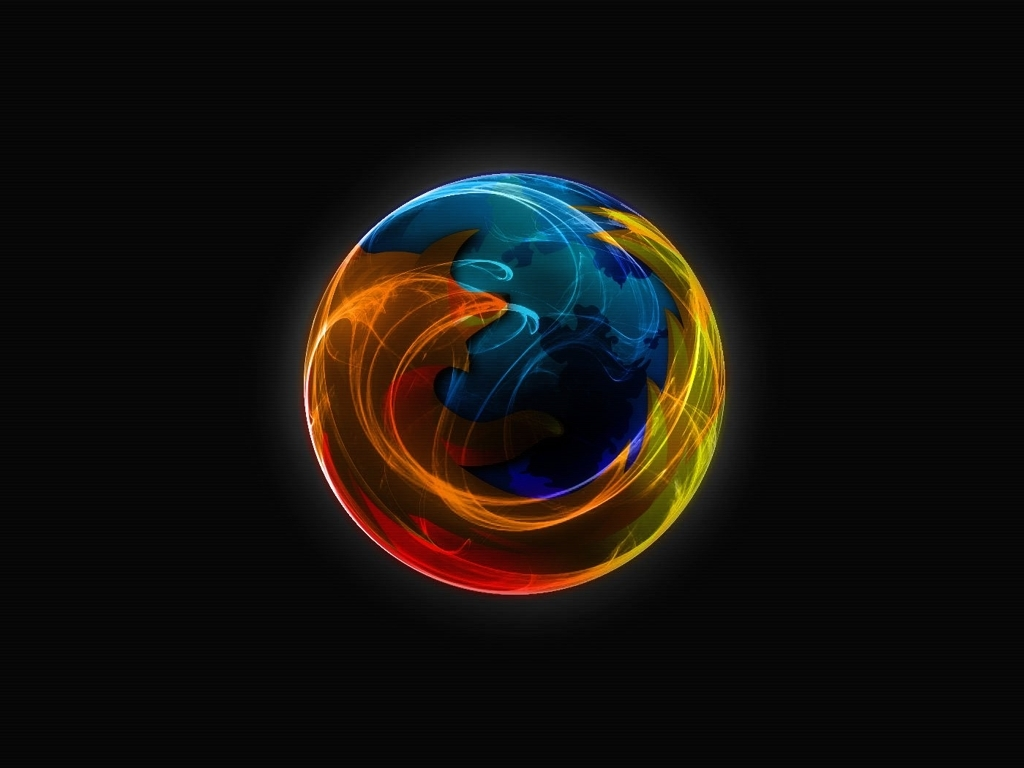Could this image have any specific symbolism? The image could symbolize the interplay between opposing forces or elements—such as fire and water—and the harmony that can exist within apparent chaos, reflecting the complex nature of reality. 